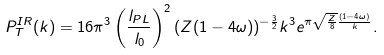<formula> <loc_0><loc_0><loc_500><loc_500>P _ { T } ^ { I R } ( k ) = 1 6 \pi ^ { 3 } \left ( \frac { l _ { P L } } { l _ { 0 } } \right ) ^ { 2 } ( Z ( 1 - 4 \omega ) ) ^ { - \frac { 3 } { 2 } } k ^ { 3 } e ^ { \pi \sqrt { \frac { Z } { 8 } } \frac { ( 1 - 4 \omega ) } { k } } .</formula> 